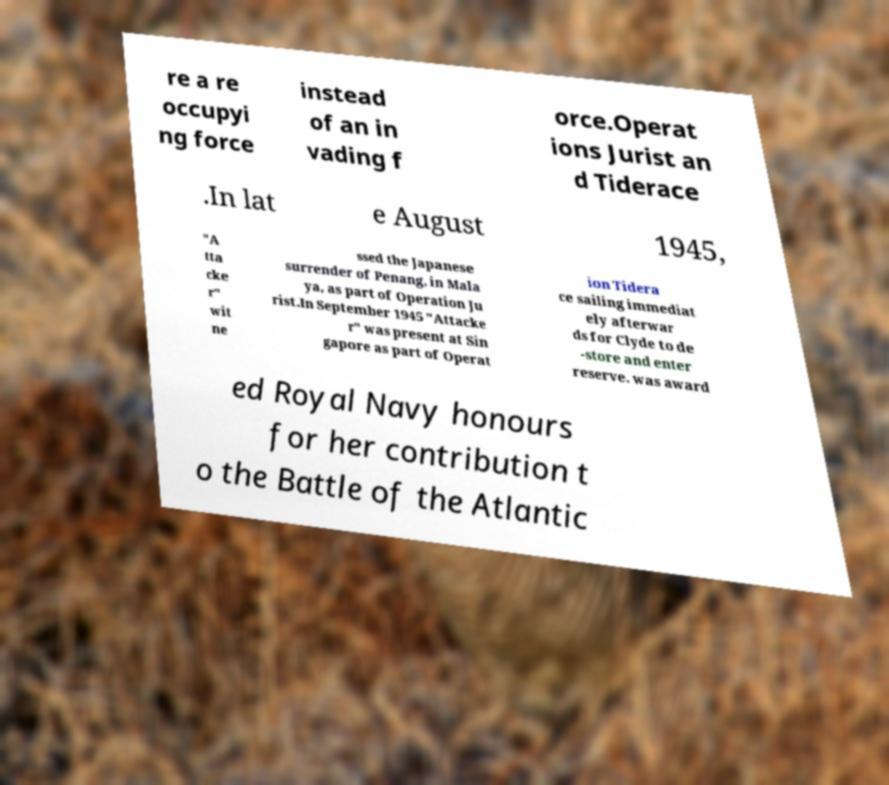For documentation purposes, I need the text within this image transcribed. Could you provide that? re a re occupyi ng force instead of an in vading f orce.Operat ions Jurist an d Tiderace .In lat e August 1945, "A tta cke r" wit ne ssed the Japanese surrender of Penang, in Mala ya, as part of Operation Ju rist.In September 1945 "Attacke r" was present at Sin gapore as part of Operat ion Tidera ce sailing immediat ely afterwar ds for Clyde to de -store and enter reserve. was award ed Royal Navy honours for her contribution t o the Battle of the Atlantic 